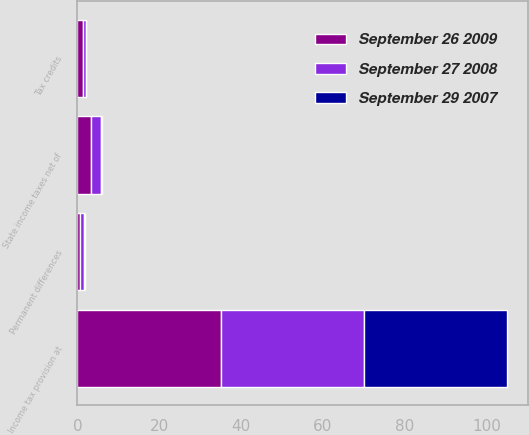Convert chart. <chart><loc_0><loc_0><loc_500><loc_500><stacked_bar_chart><ecel><fcel>Income tax provision at<fcel>State income taxes net of<fcel>Tax credits<fcel>Permanent differences<nl><fcel>September 29 2007<fcel>35<fcel>0.3<fcel>0.2<fcel>0.2<nl><fcel>September 27 2008<fcel>35<fcel>2.5<fcel>0.6<fcel>1<nl><fcel>September 26 2009<fcel>35<fcel>3.3<fcel>1.4<fcel>0.7<nl></chart> 